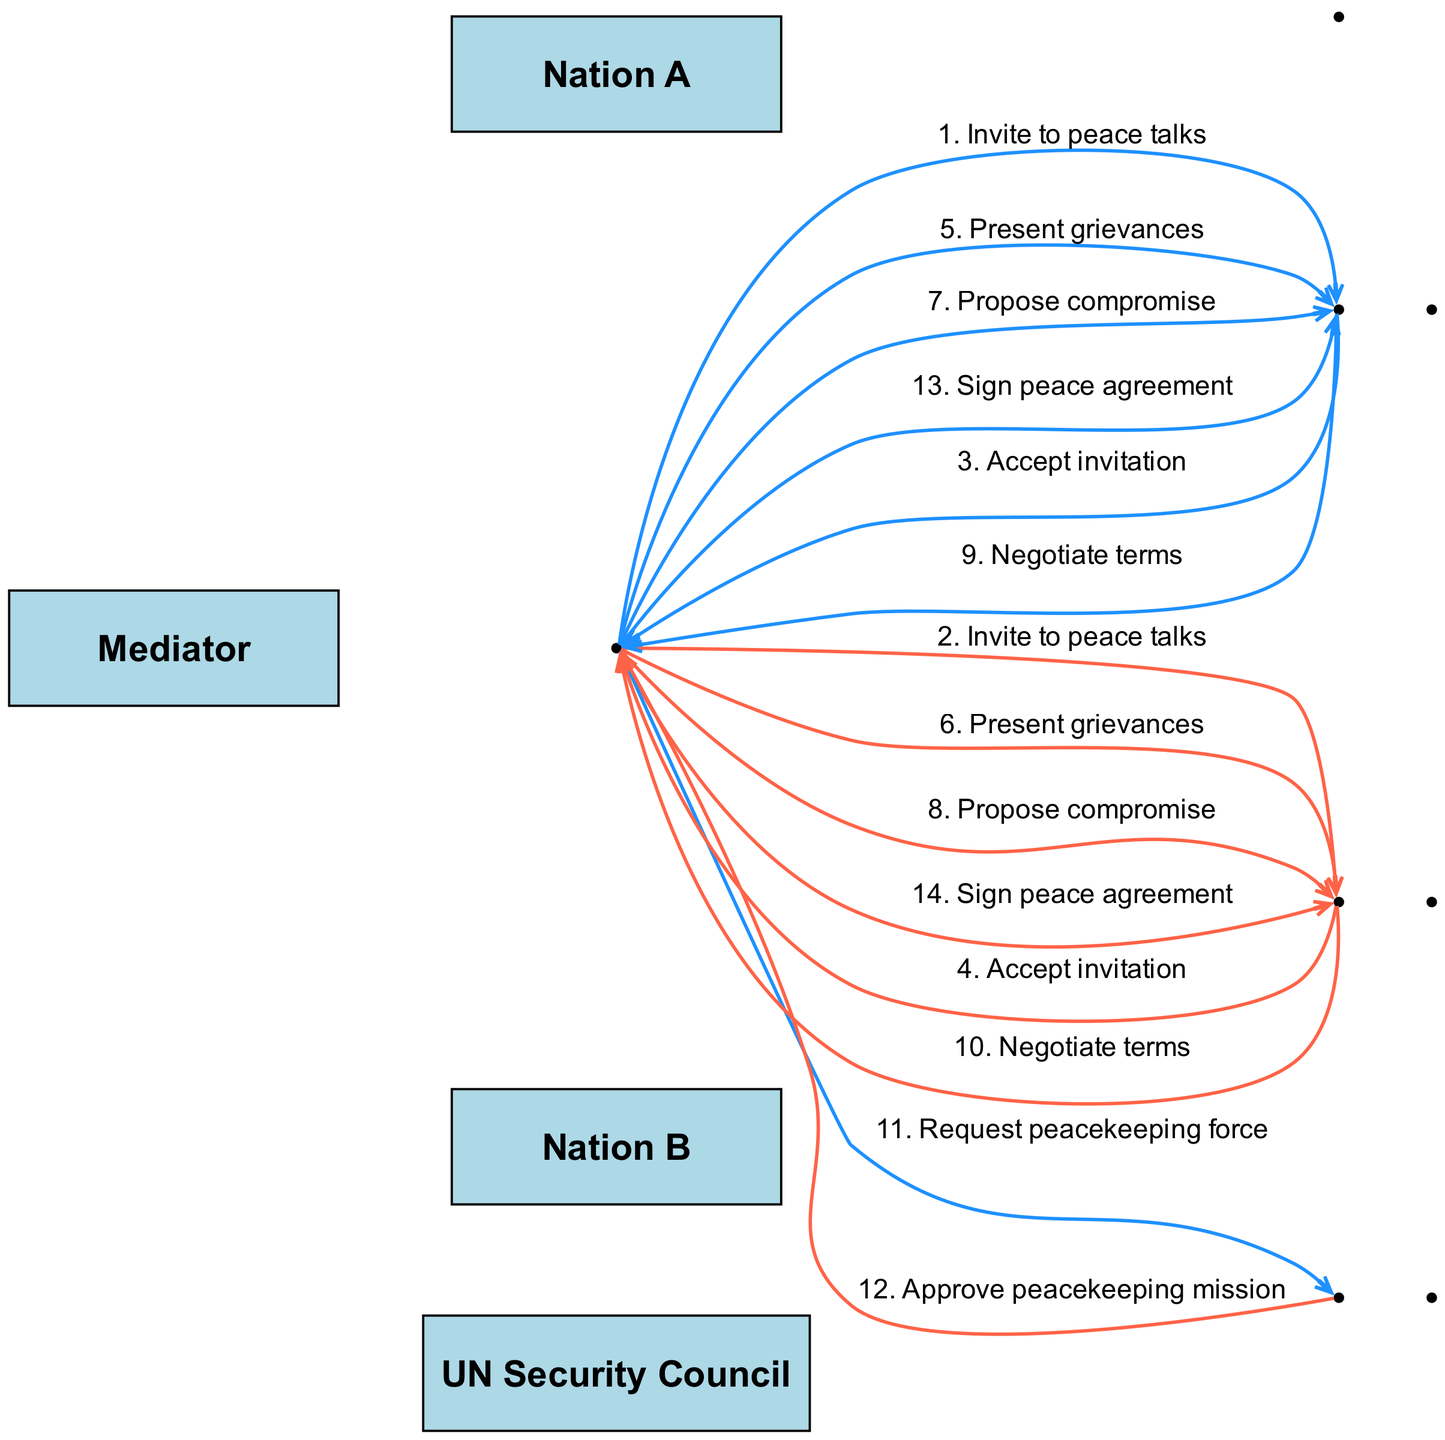What is the first action taken by the Mediator? The first action in the sequence is to "Invite to peace talks" directed to Nation A. It is the first interaction shown in the sequence diagram.
Answer: Invite to peace talks How many messages are exchanged between the Mediator and the two nations? The sequence shows a total of 8 messages exchanged between the Mediator and the two nations, with 4 messages to each nation about grievances and compromises, plus 2 about signing the peace agreement.
Answer: 8 What message does the UN Security Council send to the Mediator? The UN Security Council sends the message "Approve peacekeeping mission" to the Mediator after the request for a peacekeeping force. It is a key node depicting approval in the conflict mediation process.
Answer: Approve peacekeeping mission Which actors accept the peace talks invitation? Both Nation A and Nation B accept the invitation, as shown clearly by their respective responses depicted in the sequence diagram.
Answer: Nation A, Nation B What is the last message exchanged in the sequence? The last message in the sequence is about signing the peace agreement from the Mediator to Nation B, marking the conclusion of the conflict mediation process.
Answer: Sign peace agreement How many stages does the Mediator have in the interaction sequence? The Mediator has a total of 7 stages where they initiate actions, request approvals, and propose terms, showing their pivotal role in the sequence.
Answer: 7 What is the primary role of the UN Security Council in this mediation process? The UN Security Council primarily serves to provide an approval for a peacekeeping mission, which is essential for ensuring implementation and stabilization post-agreement.
Answer: Approve peacekeeping mission What does the Mediator do after presenting grievances to the nations? After presenting grievances, the Mediator proposes a compromise to both nations as the next step in addressing the issues raised in the peace talks.
Answer: Propose compromise 